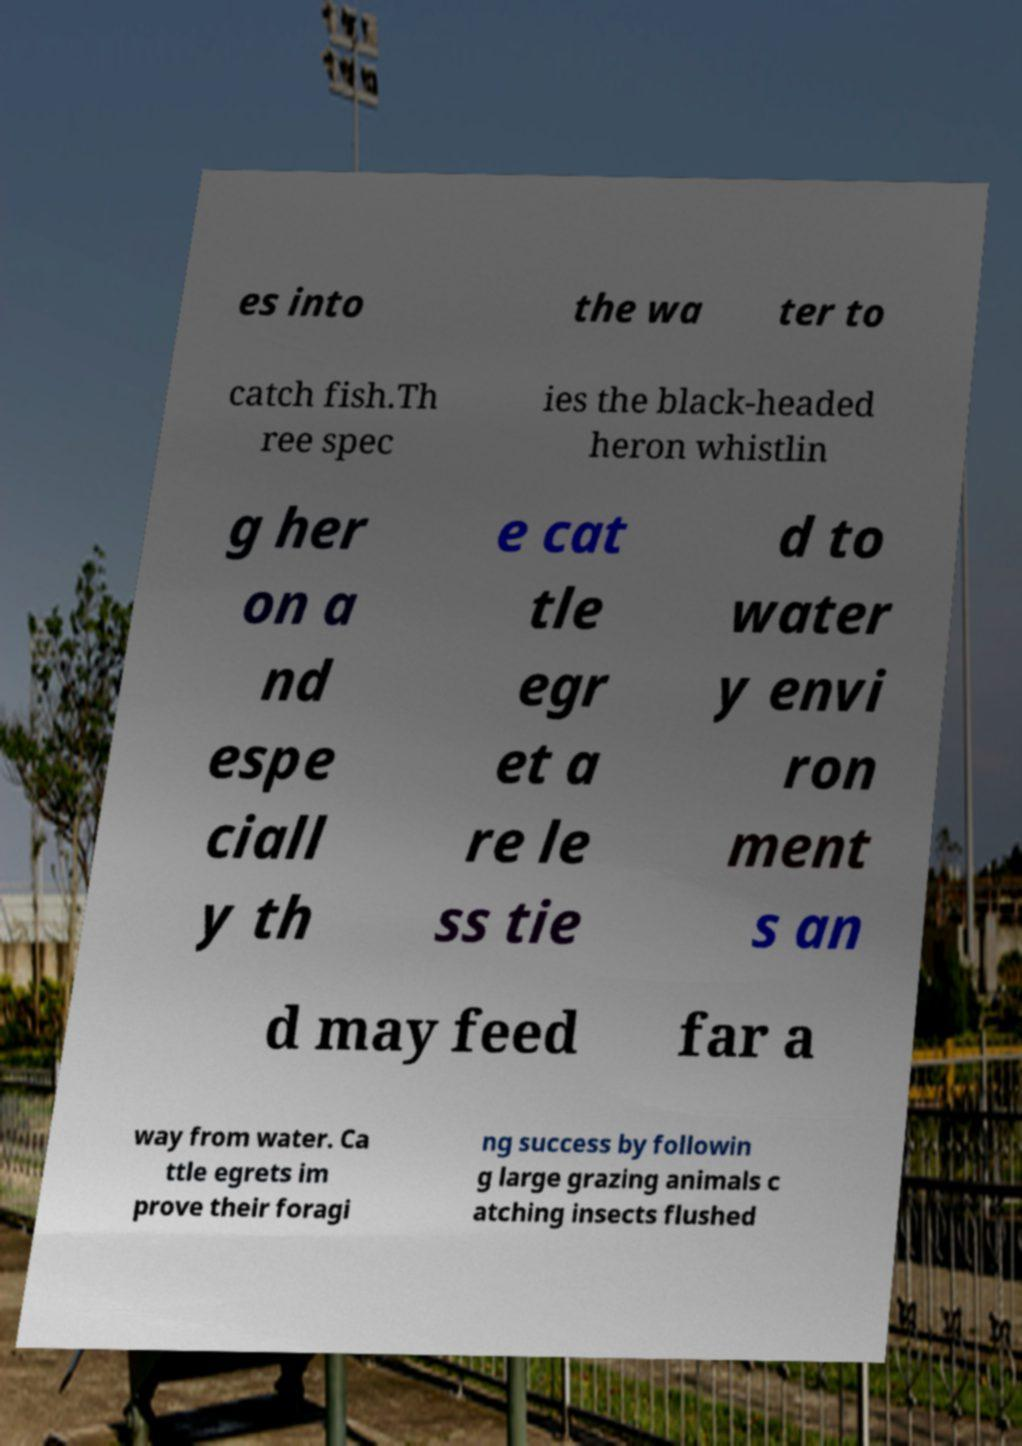I need the written content from this picture converted into text. Can you do that? es into the wa ter to catch fish.Th ree spec ies the black-headed heron whistlin g her on a nd espe ciall y th e cat tle egr et a re le ss tie d to water y envi ron ment s an d may feed far a way from water. Ca ttle egrets im prove their foragi ng success by followin g large grazing animals c atching insects flushed 